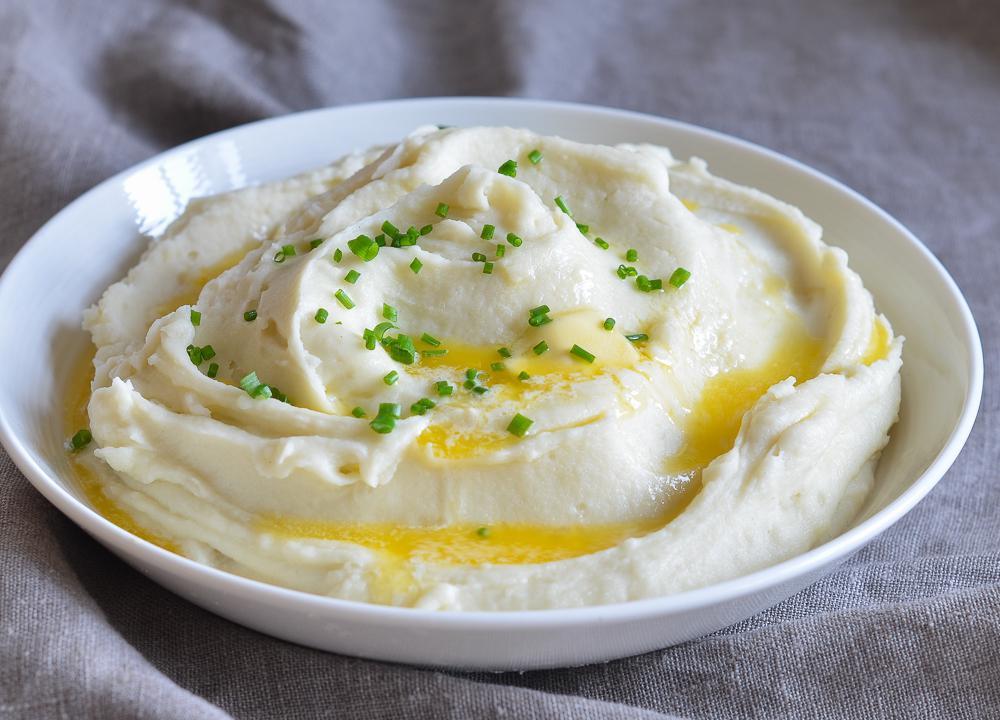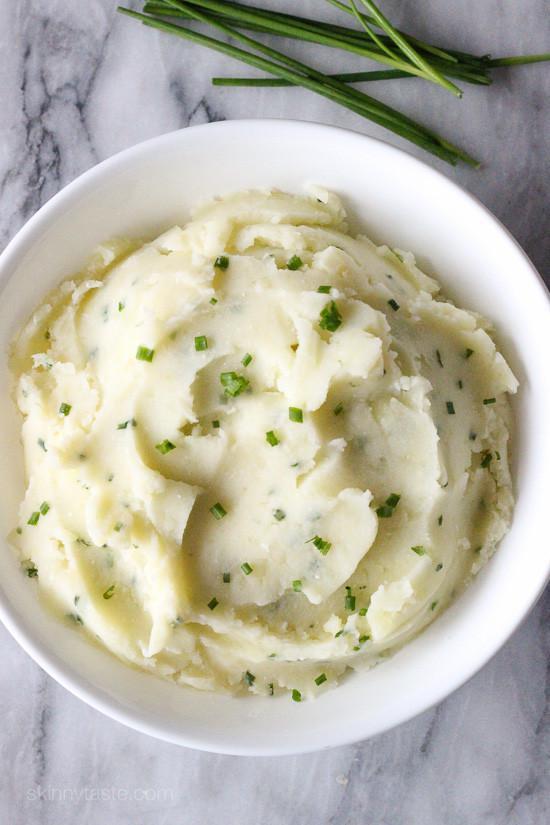The first image is the image on the left, the second image is the image on the right. Examine the images to the left and right. Is the description "The left and right image contains the same number of bowls of mash potatoes with at least one wooden bowl." accurate? Answer yes or no. No. The first image is the image on the left, the second image is the image on the right. For the images shown, is this caption "A spoon is near a round brown bowl of garnished mashed potatoes in the left image." true? Answer yes or no. No. 